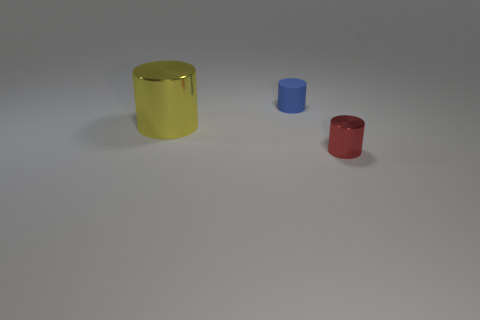Are there fewer cyan matte cylinders than big yellow cylinders?
Keep it short and to the point. Yes. The large yellow thing that is made of the same material as the tiny red thing is what shape?
Make the answer very short. Cylinder. Are there any yellow cylinders on the right side of the small red shiny object?
Your answer should be very brief. No. Is the number of metal cylinders that are on the left side of the small red shiny thing less than the number of big matte balls?
Make the answer very short. No. What is the small red object made of?
Give a very brief answer. Metal. The small rubber object has what color?
Your answer should be compact. Blue. What color is the cylinder that is behind the small red metallic cylinder and right of the big yellow cylinder?
Offer a very short reply. Blue. Are there any other things that are the same material as the large thing?
Offer a terse response. Yes. Is the big yellow cylinder made of the same material as the tiny cylinder that is left of the small red cylinder?
Your answer should be compact. No. There is a shiny object that is to the left of the metal object in front of the large cylinder; how big is it?
Provide a succinct answer. Large. 